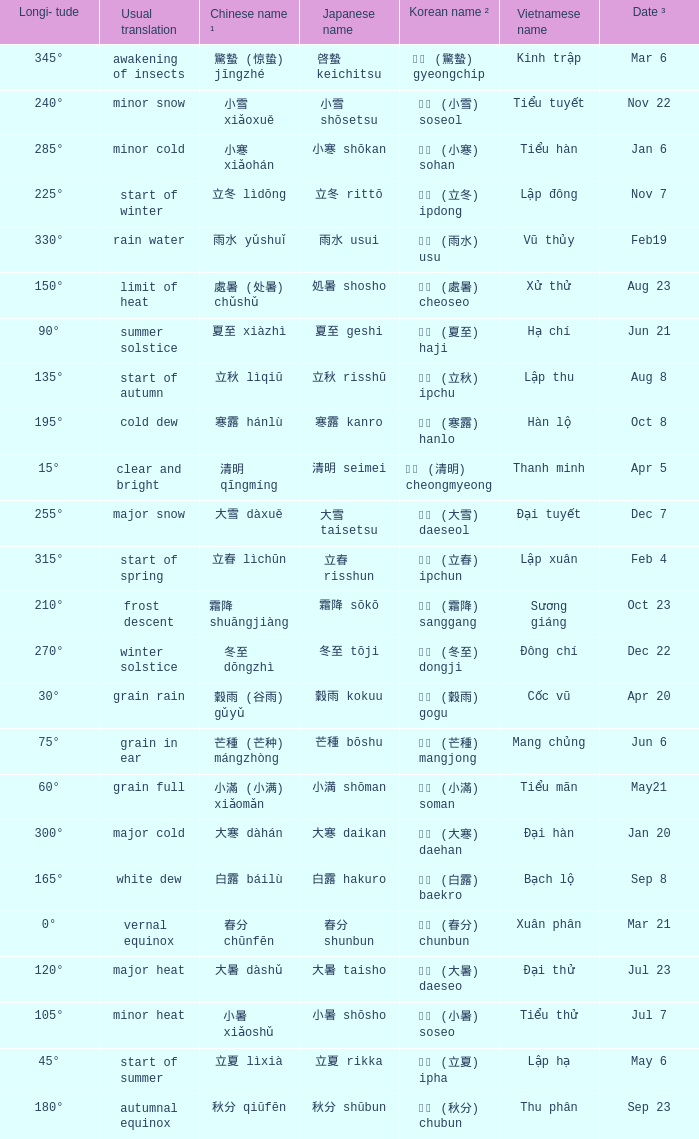When has a Korean name ² of 청명 (清明) cheongmyeong? Apr 5. 